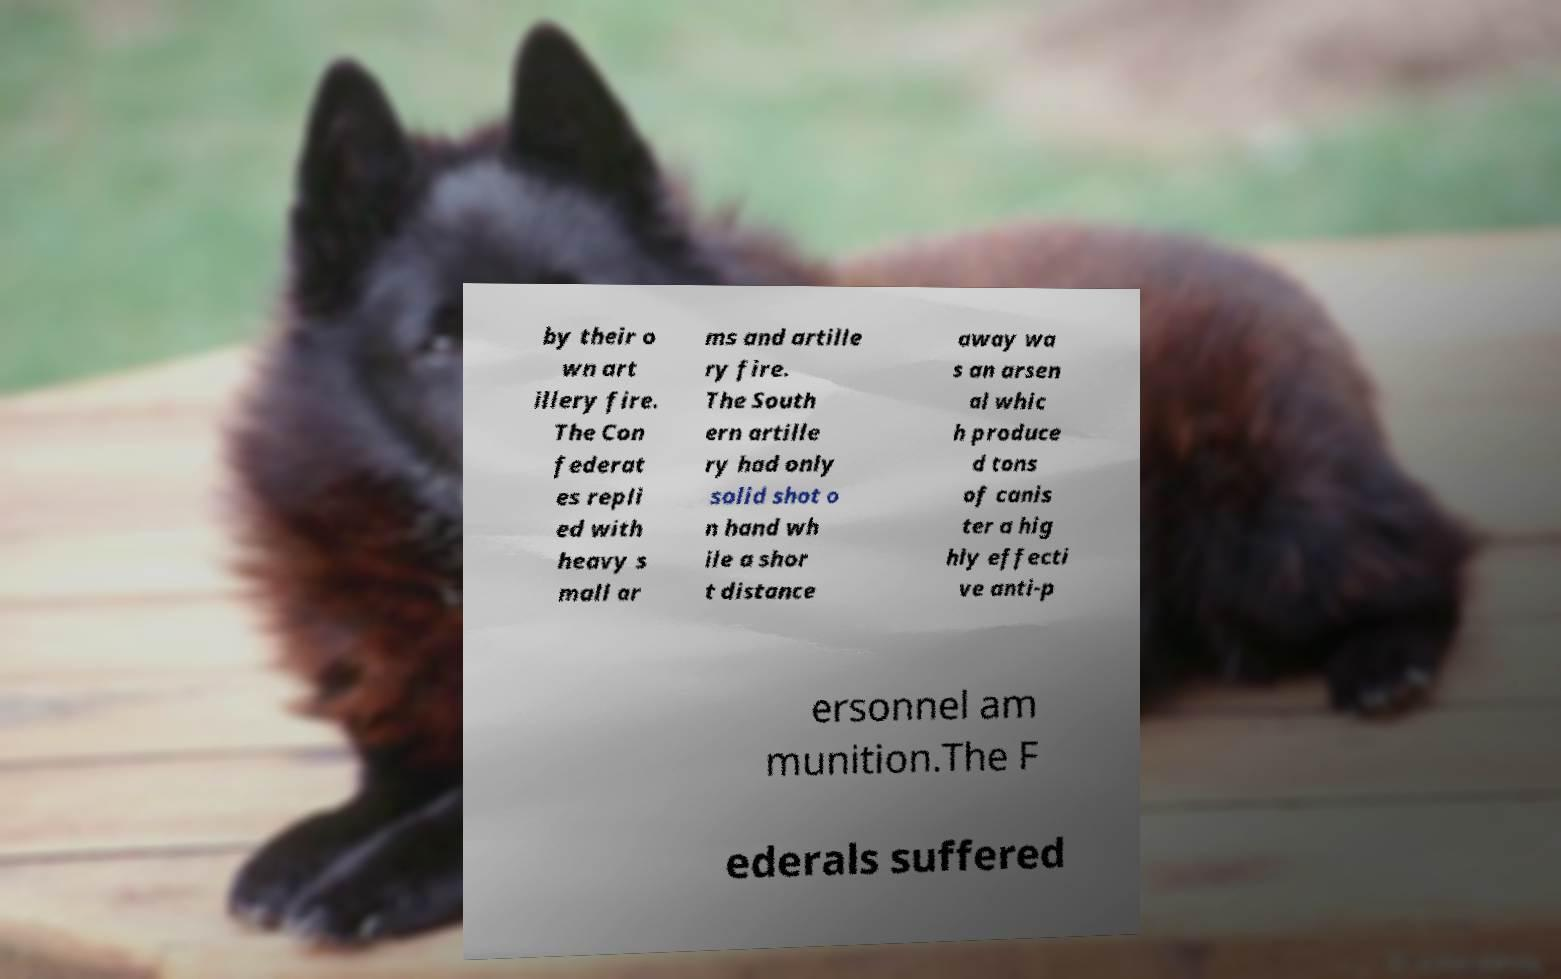Can you accurately transcribe the text from the provided image for me? by their o wn art illery fire. The Con federat es repli ed with heavy s mall ar ms and artille ry fire. The South ern artille ry had only solid shot o n hand wh ile a shor t distance away wa s an arsen al whic h produce d tons of canis ter a hig hly effecti ve anti-p ersonnel am munition.The F ederals suffered 